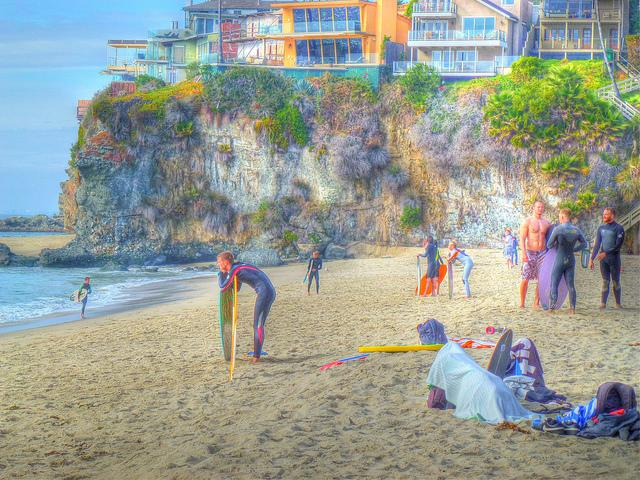What is this image? beach 